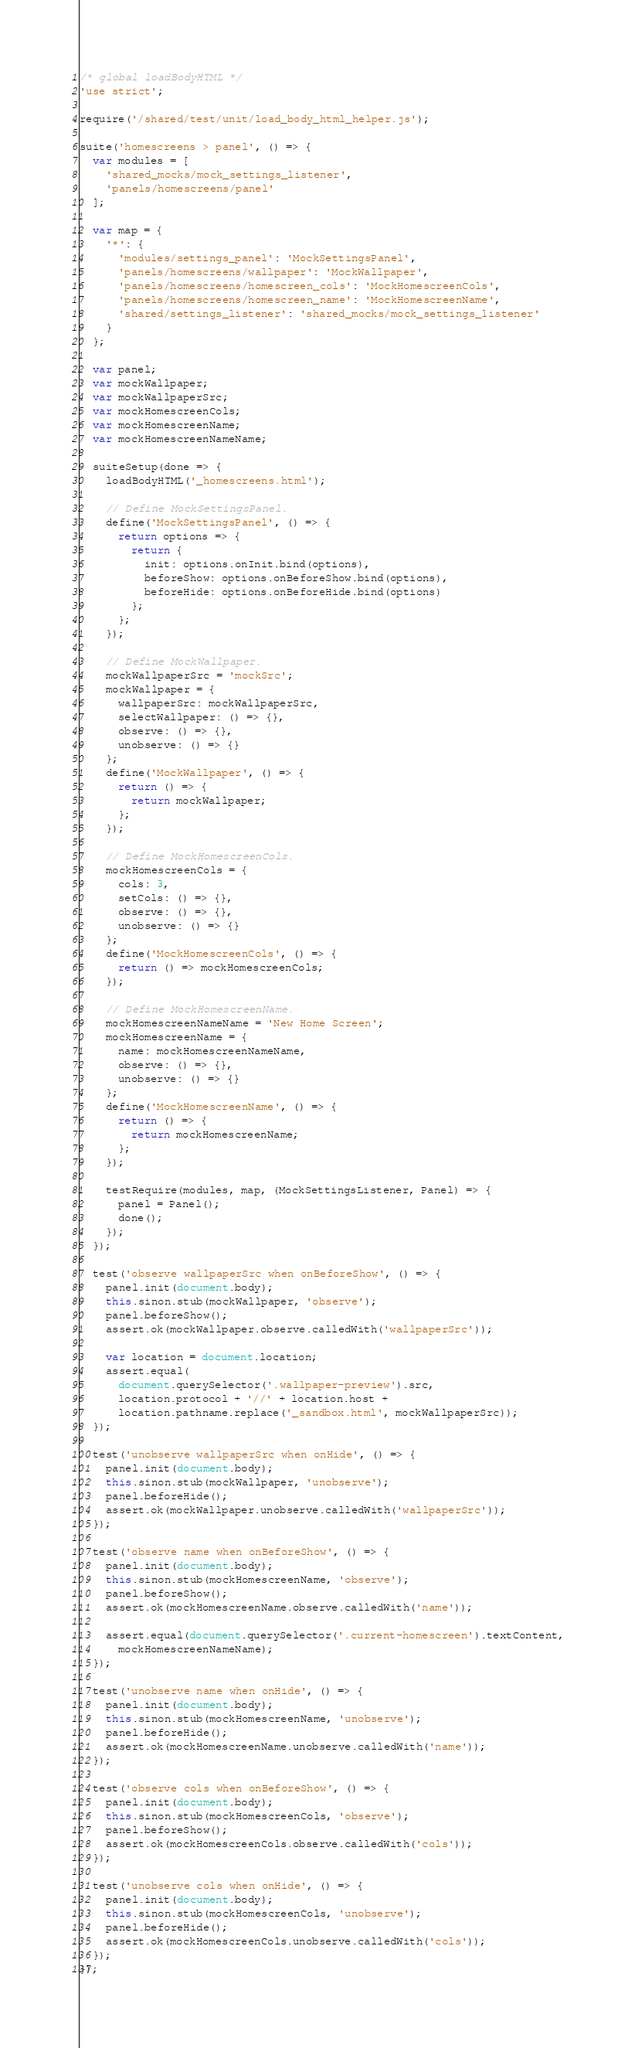Convert code to text. <code><loc_0><loc_0><loc_500><loc_500><_JavaScript_>/* global loadBodyHTML */
'use strict';

require('/shared/test/unit/load_body_html_helper.js');

suite('homescreens > panel', () => {
  var modules = [
    'shared_mocks/mock_settings_listener',
    'panels/homescreens/panel'
  ];

  var map = {
    '*': {
      'modules/settings_panel': 'MockSettingsPanel',
      'panels/homescreens/wallpaper': 'MockWallpaper',
      'panels/homescreens/homescreen_cols': 'MockHomescreenCols',
      'panels/homescreens/homescreen_name': 'MockHomescreenName',
      'shared/settings_listener': 'shared_mocks/mock_settings_listener'
    }
  };

  var panel;
  var mockWallpaper;
  var mockWallpaperSrc;
  var mockHomescreenCols;
  var mockHomescreenName;
  var mockHomescreenNameName;

  suiteSetup(done => {
    loadBodyHTML('_homescreens.html');

    // Define MockSettingsPanel.
    define('MockSettingsPanel', () => {
      return options => {
        return {
          init: options.onInit.bind(options),
          beforeShow: options.onBeforeShow.bind(options),
          beforeHide: options.onBeforeHide.bind(options)
        };
      };
    });

    // Define MockWallpaper.
    mockWallpaperSrc = 'mockSrc';
    mockWallpaper = {
      wallpaperSrc: mockWallpaperSrc,
      selectWallpaper: () => {},
      observe: () => {},
      unobserve: () => {}
    };
    define('MockWallpaper', () => {
      return () => {
        return mockWallpaper;
      };
    });

    // Define MockHomescreenCols.
    mockHomescreenCols = {
      cols: 3,
      setCols: () => {},
      observe: () => {},
      unobserve: () => {}
    };
    define('MockHomescreenCols', () => {
      return () => mockHomescreenCols;
    });

    // Define MockHomescreenName.
    mockHomescreenNameName = 'New Home Screen';
    mockHomescreenName = {
      name: mockHomescreenNameName,
      observe: () => {},
      unobserve: () => {}
    };
    define('MockHomescreenName', () => {
      return () => {
        return mockHomescreenName;
      };
    });

    testRequire(modules, map, (MockSettingsListener, Panel) => {
      panel = Panel();
      done();
    });
  });

  test('observe wallpaperSrc when onBeforeShow', () => {
    panel.init(document.body);
    this.sinon.stub(mockWallpaper, 'observe');
    panel.beforeShow();
    assert.ok(mockWallpaper.observe.calledWith('wallpaperSrc'));

    var location = document.location;
    assert.equal(
      document.querySelector('.wallpaper-preview').src,
      location.protocol + '//' + location.host +
      location.pathname.replace('_sandbox.html', mockWallpaperSrc));
  });

  test('unobserve wallpaperSrc when onHide', () => {
    panel.init(document.body);
    this.sinon.stub(mockWallpaper, 'unobserve');
    panel.beforeHide();
    assert.ok(mockWallpaper.unobserve.calledWith('wallpaperSrc'));
  });

  test('observe name when onBeforeShow', () => {
    panel.init(document.body);
    this.sinon.stub(mockHomescreenName, 'observe');
    panel.beforeShow();
    assert.ok(mockHomescreenName.observe.calledWith('name'));

    assert.equal(document.querySelector('.current-homescreen').textContent,
      mockHomescreenNameName);
  });

  test('unobserve name when onHide', () => {
    panel.init(document.body);
    this.sinon.stub(mockHomescreenName, 'unobserve');
    panel.beforeHide();
    assert.ok(mockHomescreenName.unobserve.calledWith('name'));
  });

  test('observe cols when onBeforeShow', () => {
    panel.init(document.body);
    this.sinon.stub(mockHomescreenCols, 'observe');
    panel.beforeShow();
    assert.ok(mockHomescreenCols.observe.calledWith('cols'));
  });

  test('unobserve cols when onHide', () => {
    panel.init(document.body);
    this.sinon.stub(mockHomescreenCols, 'unobserve');
    panel.beforeHide();
    assert.ok(mockHomescreenCols.unobserve.calledWith('cols'));
  });
});
</code> 